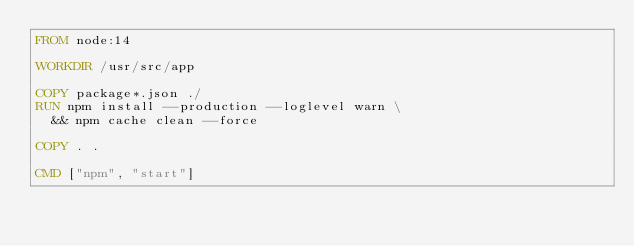<code> <loc_0><loc_0><loc_500><loc_500><_Dockerfile_>FROM node:14

WORKDIR /usr/src/app

COPY package*.json ./
RUN npm install --production --loglevel warn \
  && npm cache clean --force

COPY . .

CMD ["npm", "start"]
</code> 